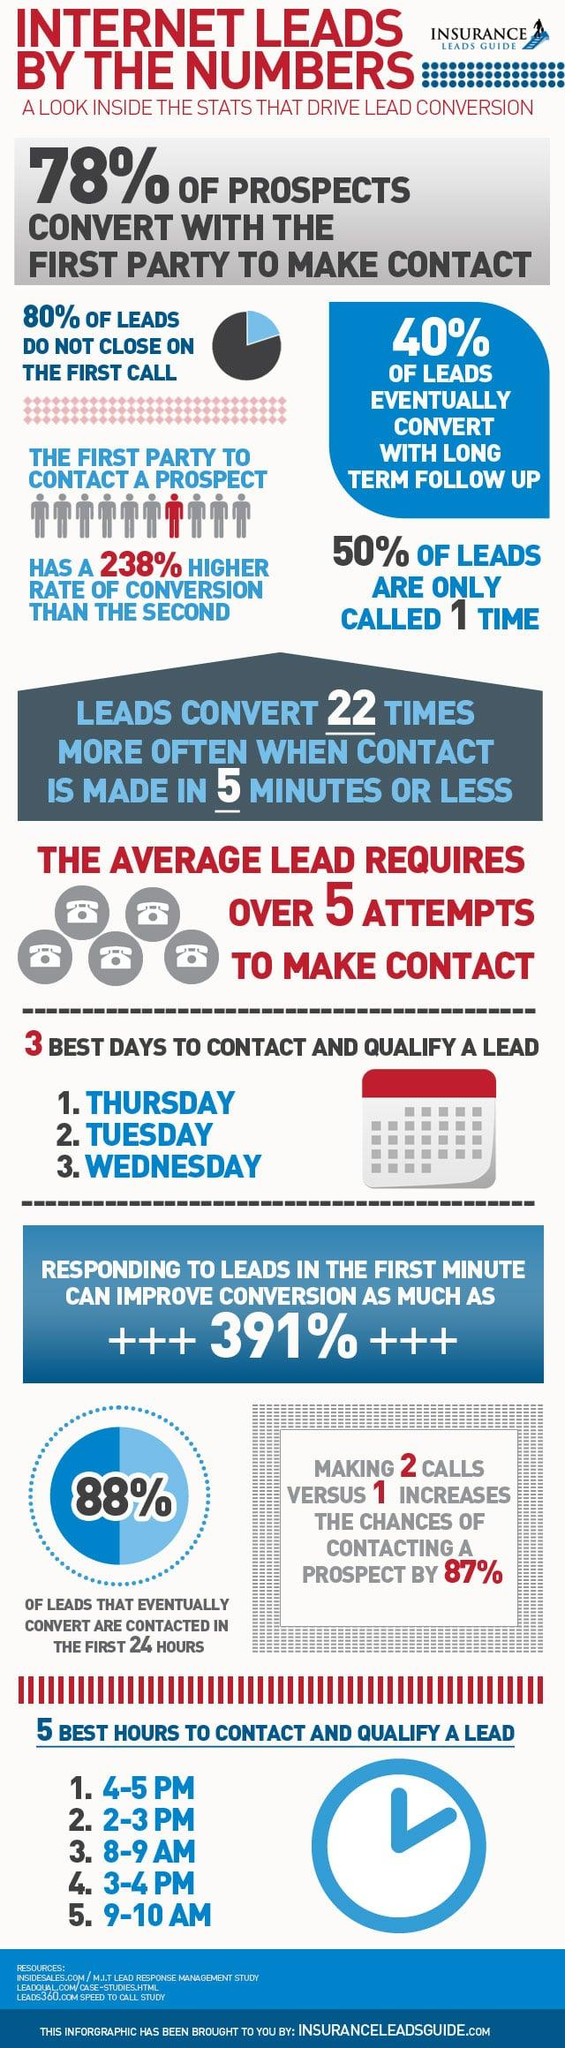Outline some significant characteristics in this image. There is a 22% chance that the second party will be able to convert internet leads into prospects. In the first call, 20% of leads are successfully converted to prospects. The ideal response time to achieve conversion rates over 300% is 1 minute or less, with 1 minute being the most effective. 